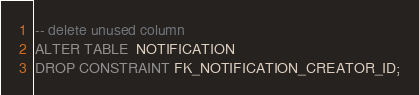<code> <loc_0><loc_0><loc_500><loc_500><_SQL_>-- delete unused column
ALTER TABLE  NOTIFICATION
DROP CONSTRAINT FK_NOTIFICATION_CREATOR_ID;</code> 